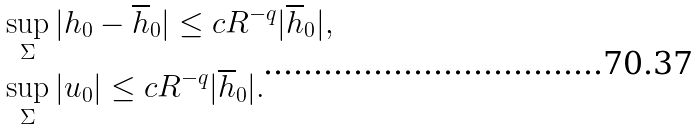<formula> <loc_0><loc_0><loc_500><loc_500>& \sup _ { \Sigma } | h _ { 0 } - \overline { h } _ { 0 } | \leq c R ^ { - q } | \overline { h } _ { 0 } | , \\ & \sup _ { \Sigma } | u _ { 0 } | \leq c R ^ { - q } | \overline { h } _ { 0 } | .</formula> 